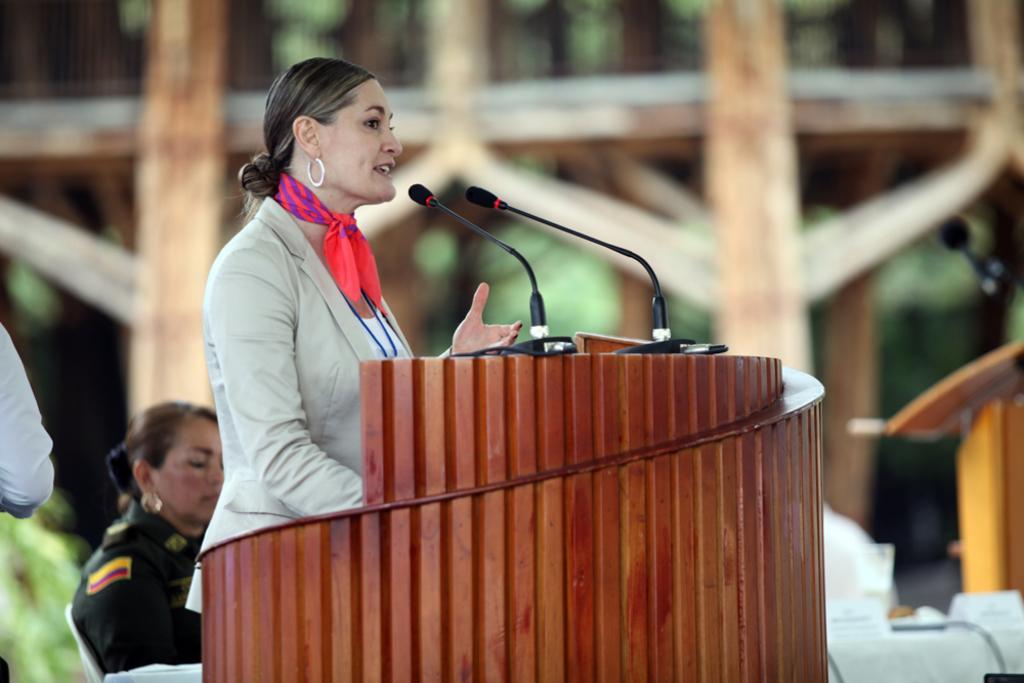Please provide a concise description of this image. Background portion of the picture is blur. In this picture we can see the boards, microphones, podiums and a chair. We can see a woman is sitting on a chair. We can see another woman standing near to a podium and talking. On the left side of the picture we can see the hand of a person. 